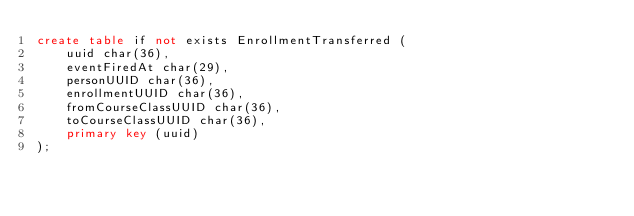Convert code to text. <code><loc_0><loc_0><loc_500><loc_500><_SQL_>create table if not exists EnrollmentTransferred (
	uuid char(36),
	eventFiredAt char(29),
	personUUID char(36),
	enrollmentUUID char(36),
	fromCourseClassUUID char(36),
	toCourseClassUUID char(36),
	primary key (uuid)
);
</code> 